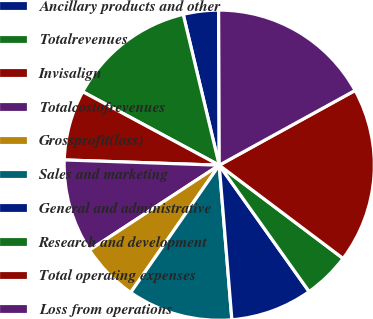Convert chart to OTSL. <chart><loc_0><loc_0><loc_500><loc_500><pie_chart><fcel>Ancillary products and other<fcel>Totalrevenues<fcel>Invisalign<fcel>Totalcostofrevenues<fcel>Grossprofit(loss)<fcel>Sales and marketing<fcel>General and administrative<fcel>Research and development<fcel>Total operating expenses<fcel>Loss from operations<nl><fcel>3.67%<fcel>13.41%<fcel>7.32%<fcel>9.76%<fcel>6.11%<fcel>10.97%<fcel>8.54%<fcel>4.89%<fcel>18.28%<fcel>17.06%<nl></chart> 